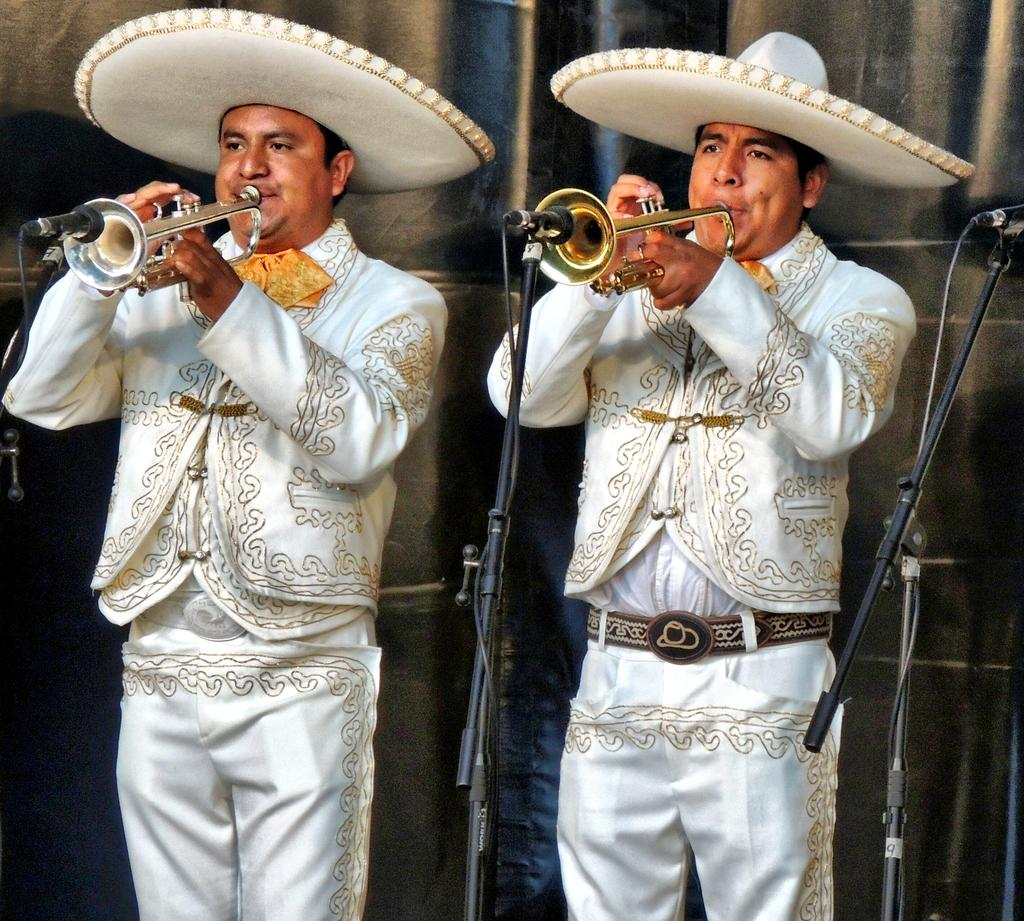How many people are in the image? There are two persons in the image. What are the persons wearing? Both persons are wearing white dress. What are the persons doing in the image? The persons are playing trumpets. How many microphones can be seen in the image? There are three microphones in the image. What is visible in the background of the image? There is a curtain in the background of the image. What type of cable can be seen connecting the persons in the image? There is no cable connecting the persons in the image; they are playing trumpets independently. Is there a writer present in the image? There is no writer present in the image; it features two persons playing trumpets. 